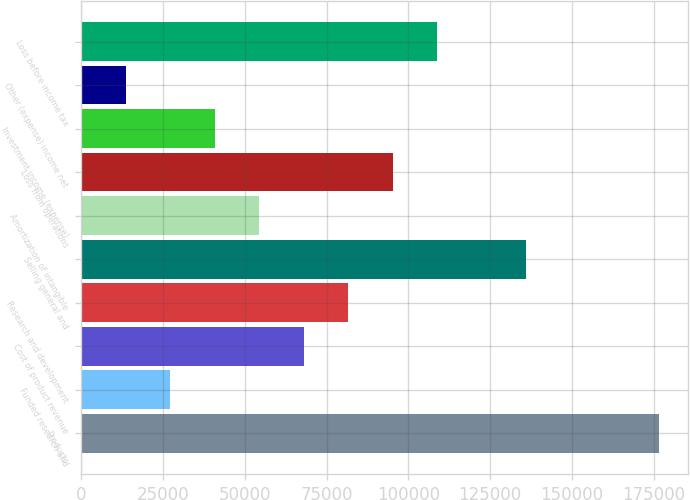Convert chart. <chart><loc_0><loc_0><loc_500><loc_500><bar_chart><fcel>Products<fcel>Funded research and<fcel>Cost of product revenue<fcel>Research and development<fcel>Selling general and<fcel>Amortization of intangible<fcel>Loss from operations<fcel>Investment income (expense)<fcel>Other (expense) income net<fcel>Loss before income tax<nl><fcel>176745<fcel>27192.3<fcel>67979.5<fcel>81575.2<fcel>135958<fcel>54383.8<fcel>95170.9<fcel>40788<fcel>13596.6<fcel>108767<nl></chart> 